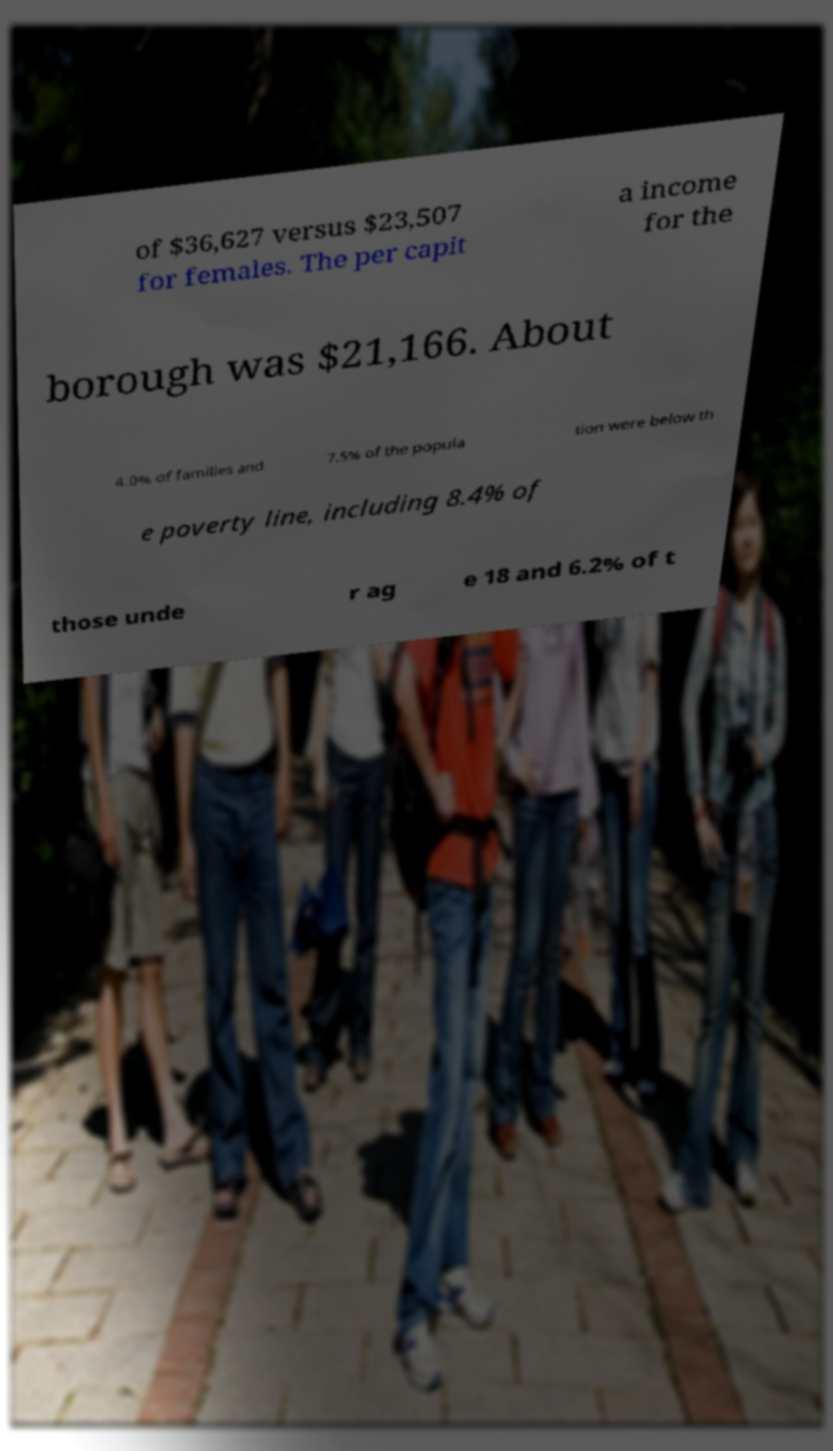For documentation purposes, I need the text within this image transcribed. Could you provide that? of $36,627 versus $23,507 for females. The per capit a income for the borough was $21,166. About 4.0% of families and 7.5% of the popula tion were below th e poverty line, including 8.4% of those unde r ag e 18 and 6.2% of t 